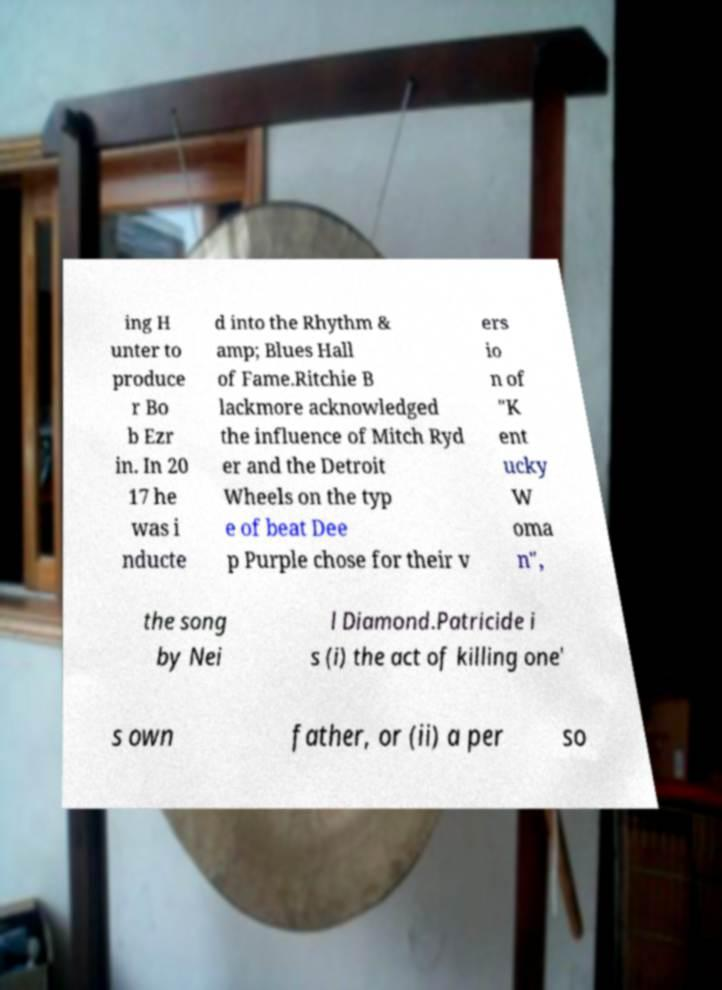I need the written content from this picture converted into text. Can you do that? ing H unter to produce r Bo b Ezr in. In 20 17 he was i nducte d into the Rhythm & amp; Blues Hall of Fame.Ritchie B lackmore acknowledged the influence of Mitch Ryd er and the Detroit Wheels on the typ e of beat Dee p Purple chose for their v ers io n of "K ent ucky W oma n", the song by Nei l Diamond.Patricide i s (i) the act of killing one' s own father, or (ii) a per so 